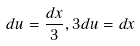Convert formula to latex. <formula><loc_0><loc_0><loc_500><loc_500>d u = \frac { d x } { 3 } , 3 d u = d x</formula> 